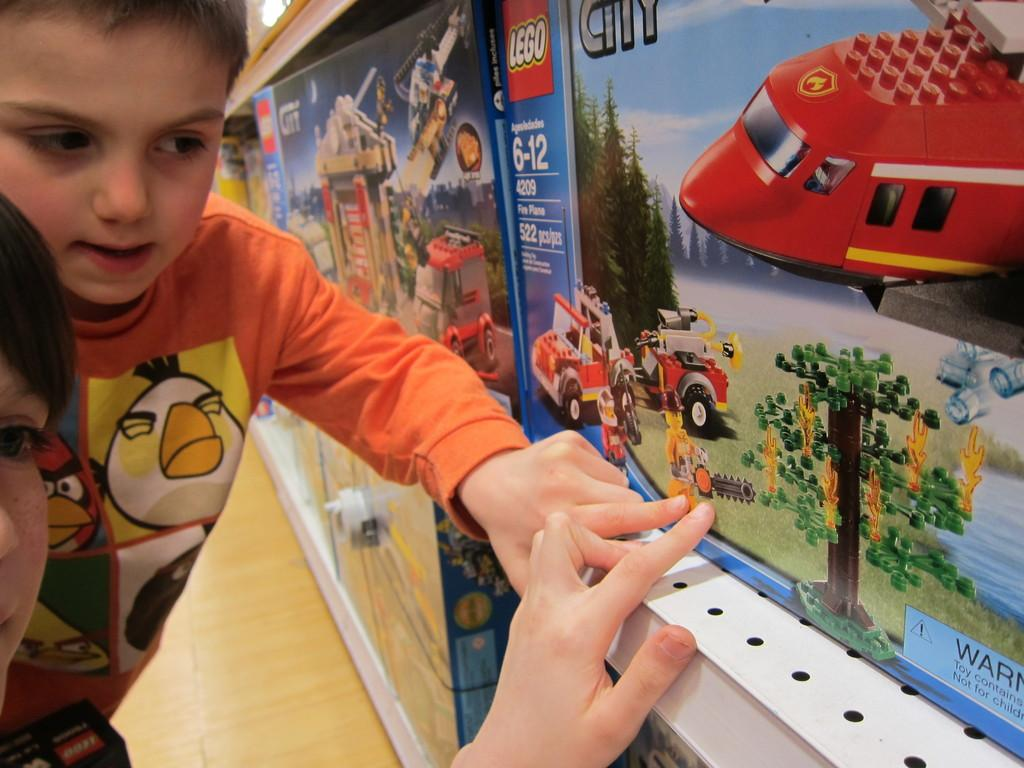<image>
Present a compact description of the photo's key features. a Lego item that a person is looking at 